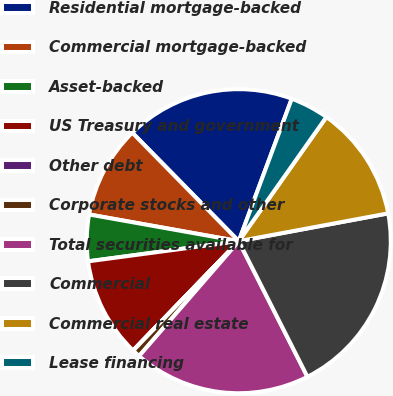Convert chart. <chart><loc_0><loc_0><loc_500><loc_500><pie_chart><fcel>Residential mortgage-backed<fcel>Commercial mortgage-backed<fcel>Asset-backed<fcel>US Treasury and government<fcel>Other debt<fcel>Corporate stocks and other<fcel>Total securities available for<fcel>Commercial<fcel>Commercial real estate<fcel>Lease financing<nl><fcel>18.02%<fcel>9.84%<fcel>4.93%<fcel>10.65%<fcel>0.02%<fcel>0.84%<fcel>18.84%<fcel>20.47%<fcel>12.29%<fcel>4.11%<nl></chart> 